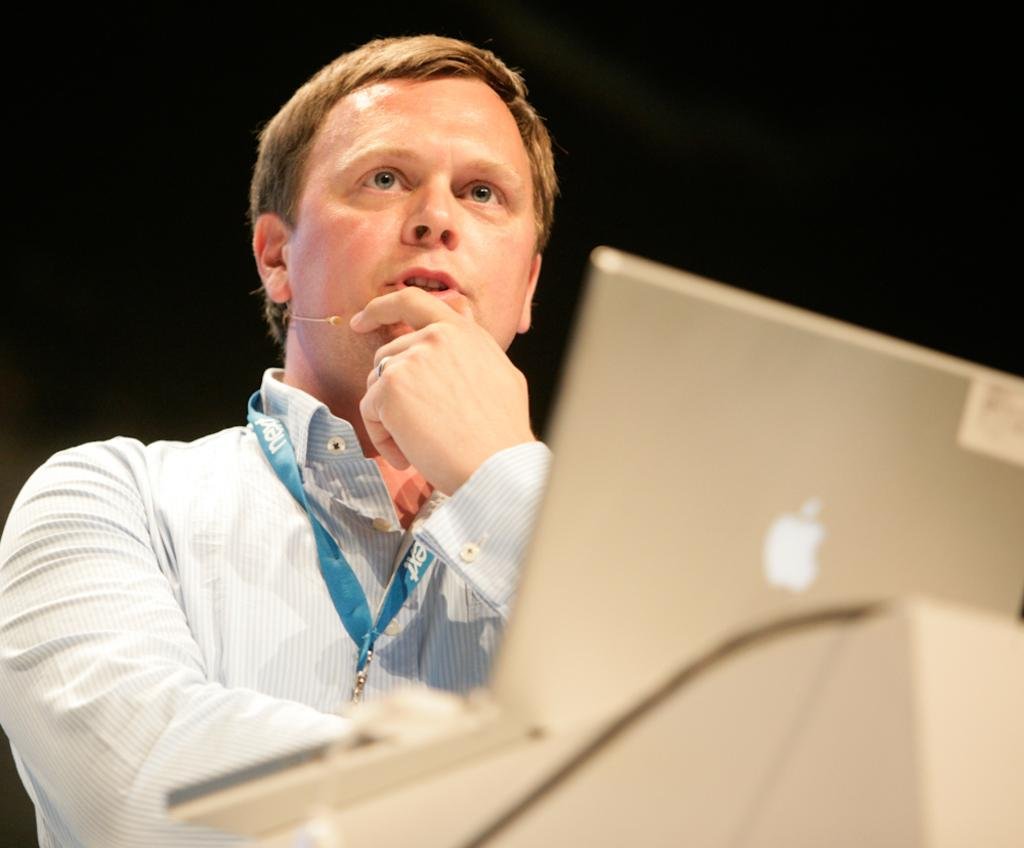Who is present in the image? There is a man in the image. What is the man wearing? The man is wearing a shirt. Does the man have any identification in the image? Yes, the man has an ID card. What electronic device is visible in the image? There is a laptop in the image. How would you describe the lighting in the image? The background of the image is dark. What type of magic is the man performing in the image? There is no indication of magic or any magical activity in the image. 